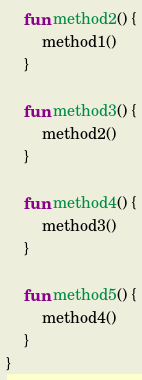<code> <loc_0><loc_0><loc_500><loc_500><_Kotlin_>    fun method2() {
        method1()
    }

    fun method3() {
        method2()
    }

    fun method4() {
        method3()
    }

    fun method5() {
        method4()
    }
}
</code> 